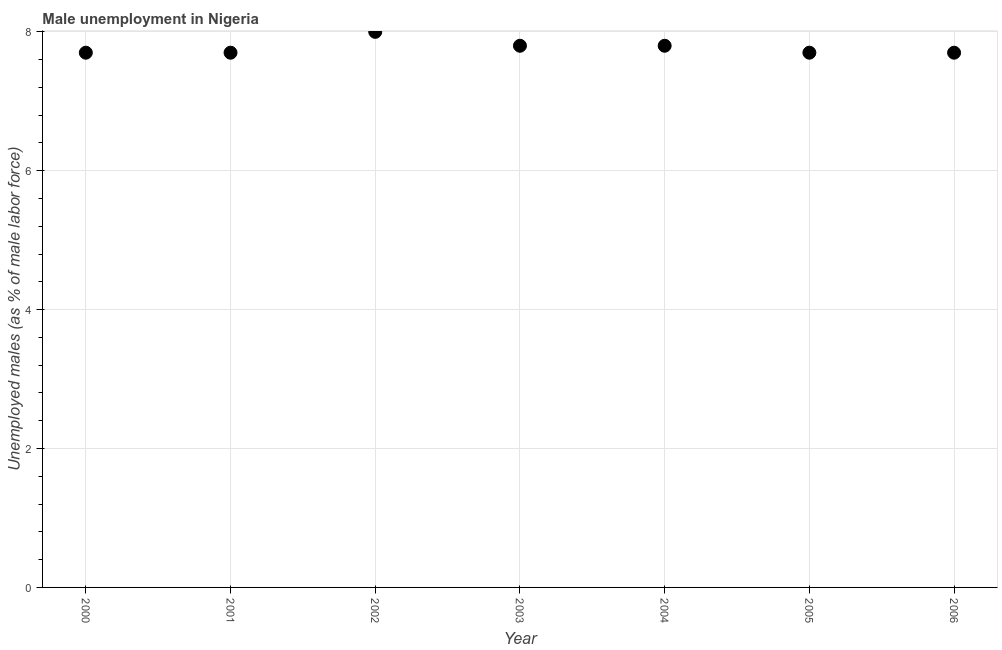What is the unemployed males population in 2002?
Offer a terse response. 8. Across all years, what is the maximum unemployed males population?
Provide a succinct answer. 8. Across all years, what is the minimum unemployed males population?
Make the answer very short. 7.7. What is the sum of the unemployed males population?
Ensure brevity in your answer.  54.4. What is the average unemployed males population per year?
Provide a short and direct response. 7.77. What is the median unemployed males population?
Your response must be concise. 7.7. Do a majority of the years between 2001 and 2000 (inclusive) have unemployed males population greater than 4.4 %?
Offer a terse response. No. What is the ratio of the unemployed males population in 2001 to that in 2006?
Offer a terse response. 1. Is the unemployed males population in 2001 less than that in 2006?
Make the answer very short. No. What is the difference between the highest and the second highest unemployed males population?
Make the answer very short. 0.2. What is the difference between the highest and the lowest unemployed males population?
Keep it short and to the point. 0.3. In how many years, is the unemployed males population greater than the average unemployed males population taken over all years?
Provide a short and direct response. 3. Does the unemployed males population monotonically increase over the years?
Offer a very short reply. No. What is the difference between two consecutive major ticks on the Y-axis?
Keep it short and to the point. 2. Are the values on the major ticks of Y-axis written in scientific E-notation?
Make the answer very short. No. What is the title of the graph?
Give a very brief answer. Male unemployment in Nigeria. What is the label or title of the X-axis?
Ensure brevity in your answer.  Year. What is the label or title of the Y-axis?
Your response must be concise. Unemployed males (as % of male labor force). What is the Unemployed males (as % of male labor force) in 2000?
Offer a terse response. 7.7. What is the Unemployed males (as % of male labor force) in 2001?
Your answer should be compact. 7.7. What is the Unemployed males (as % of male labor force) in 2003?
Offer a terse response. 7.8. What is the Unemployed males (as % of male labor force) in 2004?
Offer a terse response. 7.8. What is the Unemployed males (as % of male labor force) in 2005?
Provide a short and direct response. 7.7. What is the Unemployed males (as % of male labor force) in 2006?
Keep it short and to the point. 7.7. What is the difference between the Unemployed males (as % of male labor force) in 2000 and 2002?
Give a very brief answer. -0.3. What is the difference between the Unemployed males (as % of male labor force) in 2000 and 2004?
Provide a succinct answer. -0.1. What is the difference between the Unemployed males (as % of male labor force) in 2000 and 2005?
Keep it short and to the point. 0. What is the difference between the Unemployed males (as % of male labor force) in 2001 and 2002?
Ensure brevity in your answer.  -0.3. What is the difference between the Unemployed males (as % of male labor force) in 2001 and 2004?
Provide a short and direct response. -0.1. What is the difference between the Unemployed males (as % of male labor force) in 2001 and 2005?
Keep it short and to the point. 0. What is the difference between the Unemployed males (as % of male labor force) in 2002 and 2003?
Your answer should be compact. 0.2. What is the difference between the Unemployed males (as % of male labor force) in 2002 and 2004?
Provide a succinct answer. 0.2. What is the difference between the Unemployed males (as % of male labor force) in 2002 and 2005?
Make the answer very short. 0.3. What is the difference between the Unemployed males (as % of male labor force) in 2003 and 2004?
Your answer should be very brief. 0. What is the difference between the Unemployed males (as % of male labor force) in 2005 and 2006?
Offer a very short reply. 0. What is the ratio of the Unemployed males (as % of male labor force) in 2000 to that in 2001?
Your answer should be very brief. 1. What is the ratio of the Unemployed males (as % of male labor force) in 2000 to that in 2003?
Offer a very short reply. 0.99. What is the ratio of the Unemployed males (as % of male labor force) in 2000 to that in 2005?
Keep it short and to the point. 1. What is the ratio of the Unemployed males (as % of male labor force) in 2001 to that in 2003?
Provide a succinct answer. 0.99. What is the ratio of the Unemployed males (as % of male labor force) in 2001 to that in 2006?
Provide a succinct answer. 1. What is the ratio of the Unemployed males (as % of male labor force) in 2002 to that in 2005?
Offer a very short reply. 1.04. What is the ratio of the Unemployed males (as % of male labor force) in 2002 to that in 2006?
Provide a succinct answer. 1.04. What is the ratio of the Unemployed males (as % of male labor force) in 2003 to that in 2005?
Your answer should be compact. 1.01. What is the ratio of the Unemployed males (as % of male labor force) in 2003 to that in 2006?
Your answer should be very brief. 1.01. What is the ratio of the Unemployed males (as % of male labor force) in 2004 to that in 2005?
Ensure brevity in your answer.  1.01. What is the ratio of the Unemployed males (as % of male labor force) in 2004 to that in 2006?
Make the answer very short. 1.01. 